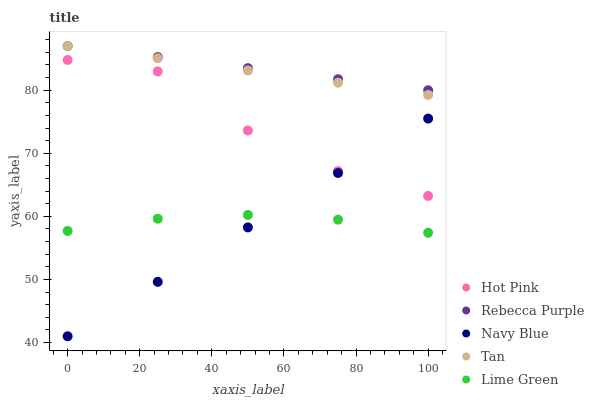Does Navy Blue have the minimum area under the curve?
Answer yes or no. Yes. Does Rebecca Purple have the maximum area under the curve?
Answer yes or no. Yes. Does Tan have the minimum area under the curve?
Answer yes or no. No. Does Tan have the maximum area under the curve?
Answer yes or no. No. Is Navy Blue the smoothest?
Answer yes or no. Yes. Is Hot Pink the roughest?
Answer yes or no. Yes. Is Tan the smoothest?
Answer yes or no. No. Is Tan the roughest?
Answer yes or no. No. Does Navy Blue have the lowest value?
Answer yes or no. Yes. Does Tan have the lowest value?
Answer yes or no. No. Does Rebecca Purple have the highest value?
Answer yes or no. Yes. Does Hot Pink have the highest value?
Answer yes or no. No. Is Lime Green less than Hot Pink?
Answer yes or no. Yes. Is Rebecca Purple greater than Hot Pink?
Answer yes or no. Yes. Does Lime Green intersect Navy Blue?
Answer yes or no. Yes. Is Lime Green less than Navy Blue?
Answer yes or no. No. Is Lime Green greater than Navy Blue?
Answer yes or no. No. Does Lime Green intersect Hot Pink?
Answer yes or no. No. 